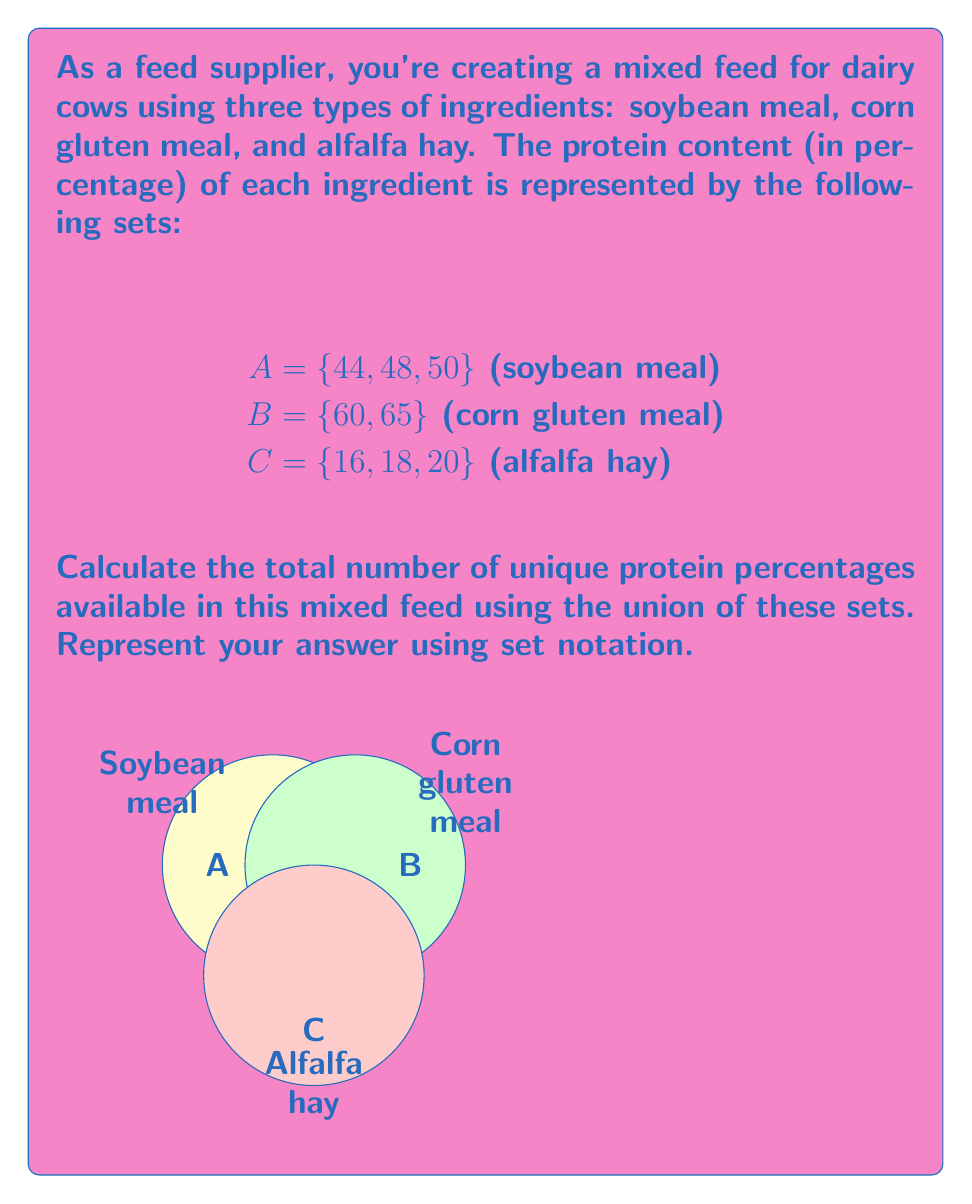Can you solve this math problem? To solve this problem, we need to find the union of sets A, B, and C. The union of sets includes all unique elements from all sets without repetition.

Step 1: Write out the union of sets A, B, and C.
$$ A \cup B \cup C = \{44, 48, 50\} \cup \{60, 65\} \cup \{16, 18, 20\} $$

Step 2: Combine all elements from the three sets.
$$ A \cup B \cup C = \{16, 18, 20, 44, 48, 50, 60, 65\} $$

Step 3: Count the number of unique elements in the resulting set.
There are 8 unique elements in the union of sets A, B, and C.

Therefore, there are 8 unique protein percentages available in this mixed feed.
Answer: $|A \cup B \cup C| = 8$ 